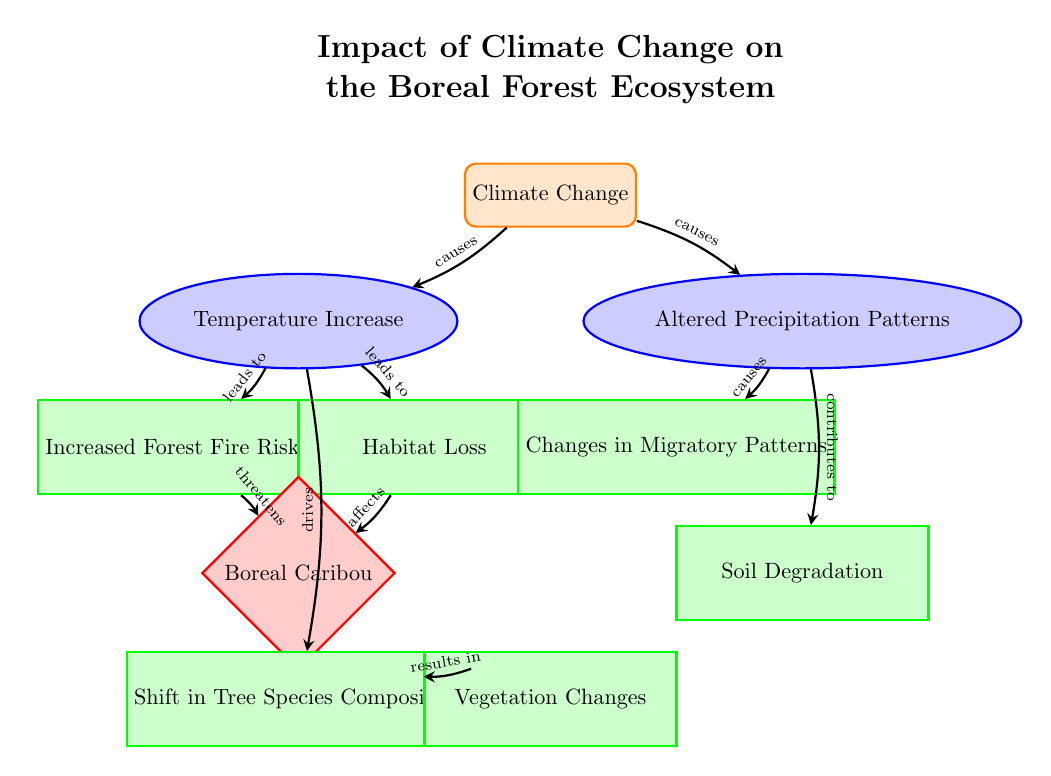What is the main factor identified in the diagram? The diagram explicitly labels "Climate Change" as the main factor at the top center. This node serves as the origin for all other effects and impacts designated in the diagram.
Answer: Climate Change How many impacts are directly linked to temperature increase? From the "Temperature Increase" node, there are two arrows leading to "Increased Forest Fire Risk" and "Habitat Loss," indicating that temperature increase has two direct impacts.
Answer: 2 Which species is specifically threatened by increased forest fire risk? The diagram shows an arrow from "Increased Forest Fire Risk" pointing to "Boreal Caribou," indicating that this species is specifically threatened by this factor.
Answer: Boreal Caribou What impact is related to altered precipitation patterns? The diagram shows an arrow from "Altered Precipitation Patterns" pointing to "Changes in Migratory Patterns," indicating that this is a direct impact of altered precipitation.
Answer: Changes in Migratory Patterns What effect is indicated to result from a shift in tree species composition? The diagram connects "Tree Species Shift" to "Vegetation Changes," indicating that this is the effect resulting from the shift in tree species.
Answer: Vegetation Changes What effect does temperature increase have on tree species? "Temperature Increase" drives "Tree Species Shift," as indicated by the arrow from temperature increase pointing to the tree species shift.
Answer: Tree Species Shift How does altered precipitation contribute to soil degradation? The diagram indicates a causal relationship where "Altered Precipitation Patterns" contribute to "Soil Degradation," shown by the arrow connecting these two nodes.
Answer: Contributes to What number of factors does climate change affect directly? Climate change has two direct relationships represented by arrows pointing to "Temperature Increase" and "Altered Precipitation Patterns." Thus, it affects two factors directly.
Answer: 2 